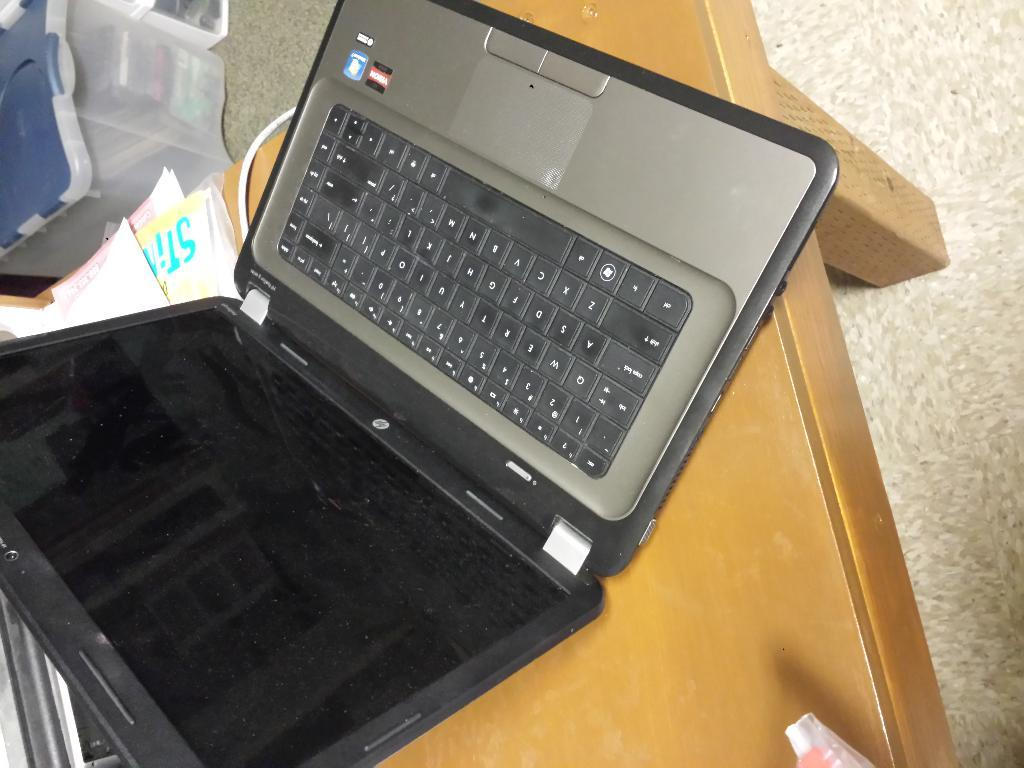<image>
Offer a succinct explanation of the picture presented. A windows computer that is sitting on a desk. 